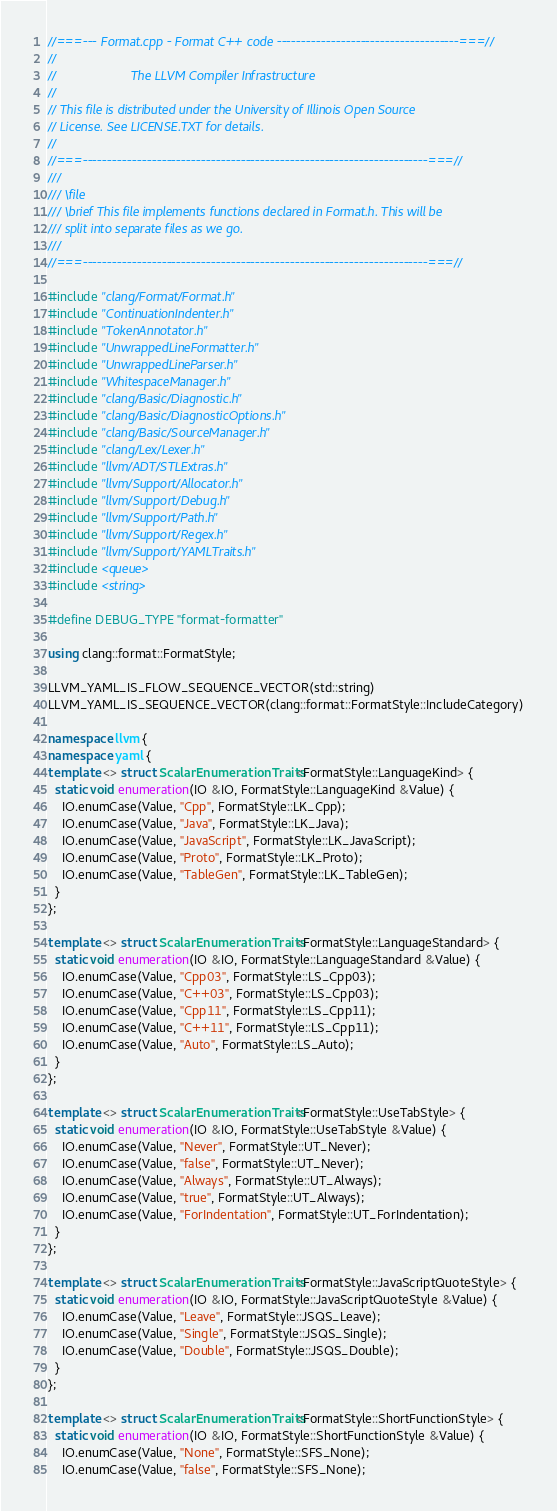<code> <loc_0><loc_0><loc_500><loc_500><_C++_>//===--- Format.cpp - Format C++ code -------------------------------------===//
//
//                     The LLVM Compiler Infrastructure
//
// This file is distributed under the University of Illinois Open Source
// License. See LICENSE.TXT for details.
//
//===----------------------------------------------------------------------===//
///
/// \file
/// \brief This file implements functions declared in Format.h. This will be
/// split into separate files as we go.
///
//===----------------------------------------------------------------------===//

#include "clang/Format/Format.h"
#include "ContinuationIndenter.h"
#include "TokenAnnotator.h"
#include "UnwrappedLineFormatter.h"
#include "UnwrappedLineParser.h"
#include "WhitespaceManager.h"
#include "clang/Basic/Diagnostic.h"
#include "clang/Basic/DiagnosticOptions.h"
#include "clang/Basic/SourceManager.h"
#include "clang/Lex/Lexer.h"
#include "llvm/ADT/STLExtras.h"
#include "llvm/Support/Allocator.h"
#include "llvm/Support/Debug.h"
#include "llvm/Support/Path.h"
#include "llvm/Support/Regex.h"
#include "llvm/Support/YAMLTraits.h"
#include <queue>
#include <string>

#define DEBUG_TYPE "format-formatter"

using clang::format::FormatStyle;

LLVM_YAML_IS_FLOW_SEQUENCE_VECTOR(std::string)
LLVM_YAML_IS_SEQUENCE_VECTOR(clang::format::FormatStyle::IncludeCategory)

namespace llvm {
namespace yaml {
template <> struct ScalarEnumerationTraits<FormatStyle::LanguageKind> {
  static void enumeration(IO &IO, FormatStyle::LanguageKind &Value) {
    IO.enumCase(Value, "Cpp", FormatStyle::LK_Cpp);
    IO.enumCase(Value, "Java", FormatStyle::LK_Java);
    IO.enumCase(Value, "JavaScript", FormatStyle::LK_JavaScript);
    IO.enumCase(Value, "Proto", FormatStyle::LK_Proto);
    IO.enumCase(Value, "TableGen", FormatStyle::LK_TableGen);
  }
};

template <> struct ScalarEnumerationTraits<FormatStyle::LanguageStandard> {
  static void enumeration(IO &IO, FormatStyle::LanguageStandard &Value) {
    IO.enumCase(Value, "Cpp03", FormatStyle::LS_Cpp03);
    IO.enumCase(Value, "C++03", FormatStyle::LS_Cpp03);
    IO.enumCase(Value, "Cpp11", FormatStyle::LS_Cpp11);
    IO.enumCase(Value, "C++11", FormatStyle::LS_Cpp11);
    IO.enumCase(Value, "Auto", FormatStyle::LS_Auto);
  }
};

template <> struct ScalarEnumerationTraits<FormatStyle::UseTabStyle> {
  static void enumeration(IO &IO, FormatStyle::UseTabStyle &Value) {
    IO.enumCase(Value, "Never", FormatStyle::UT_Never);
    IO.enumCase(Value, "false", FormatStyle::UT_Never);
    IO.enumCase(Value, "Always", FormatStyle::UT_Always);
    IO.enumCase(Value, "true", FormatStyle::UT_Always);
    IO.enumCase(Value, "ForIndentation", FormatStyle::UT_ForIndentation);
  }
};

template <> struct ScalarEnumerationTraits<FormatStyle::JavaScriptQuoteStyle> {
  static void enumeration(IO &IO, FormatStyle::JavaScriptQuoteStyle &Value) {
    IO.enumCase(Value, "Leave", FormatStyle::JSQS_Leave);
    IO.enumCase(Value, "Single", FormatStyle::JSQS_Single);
    IO.enumCase(Value, "Double", FormatStyle::JSQS_Double);
  }
};

template <> struct ScalarEnumerationTraits<FormatStyle::ShortFunctionStyle> {
  static void enumeration(IO &IO, FormatStyle::ShortFunctionStyle &Value) {
    IO.enumCase(Value, "None", FormatStyle::SFS_None);
    IO.enumCase(Value, "false", FormatStyle::SFS_None);</code> 